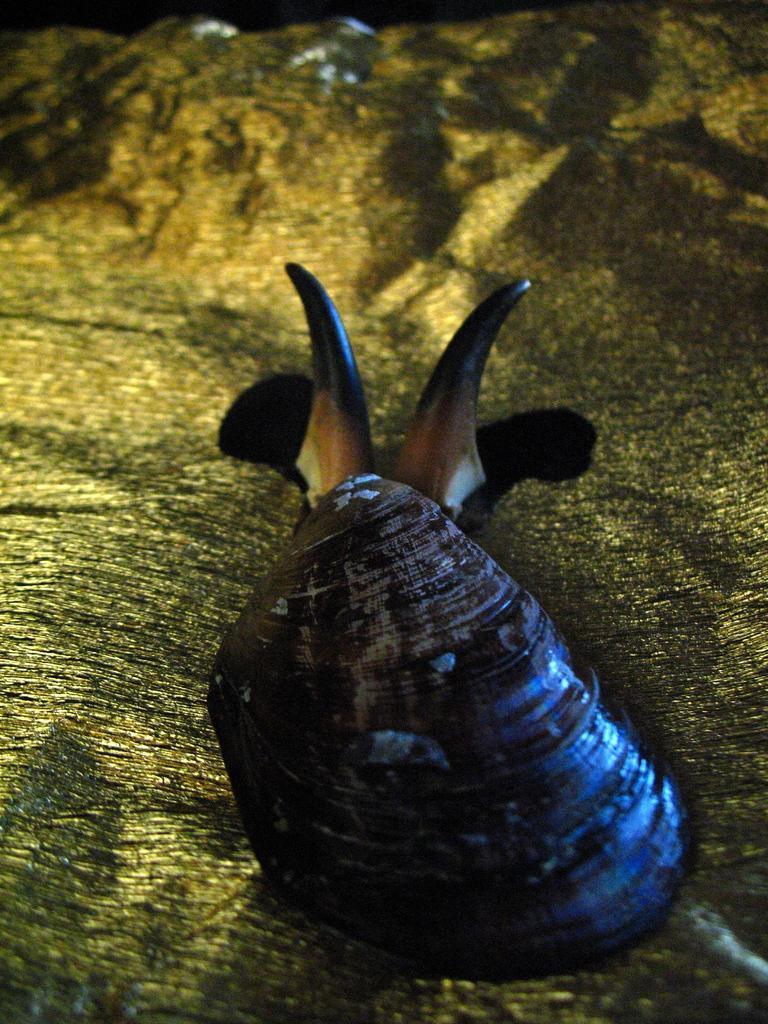In one or two sentences, can you explain what this image depicts? In this image I can see a snail on a wooden surface. 